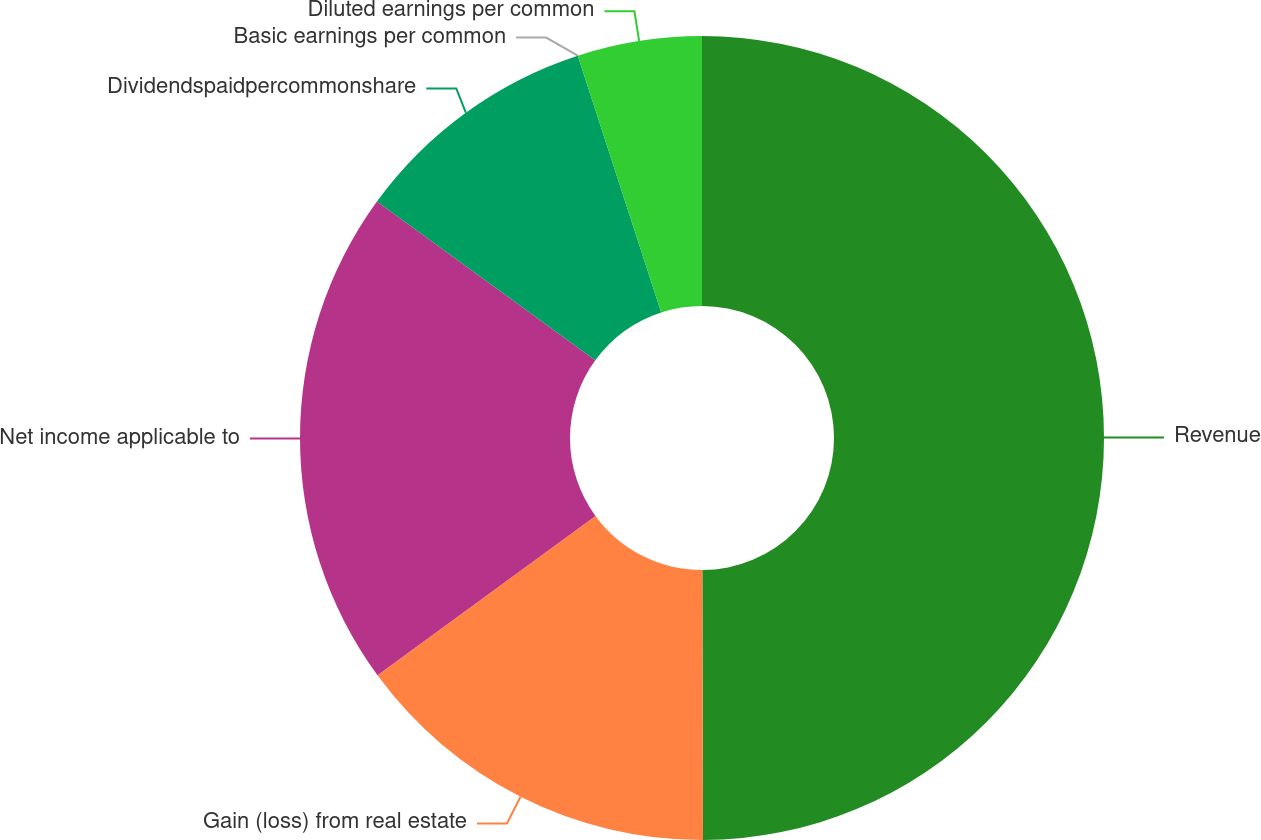Convert chart to OTSL. <chart><loc_0><loc_0><loc_500><loc_500><pie_chart><fcel>Revenue<fcel>Gain (loss) from real estate<fcel>Net income applicable to<fcel>Dividendspaidpercommonshare<fcel>Basic earnings per common<fcel>Diluted earnings per common<nl><fcel>49.96%<fcel>14.99%<fcel>20.06%<fcel>9.99%<fcel>0.0%<fcel>5.0%<nl></chart> 